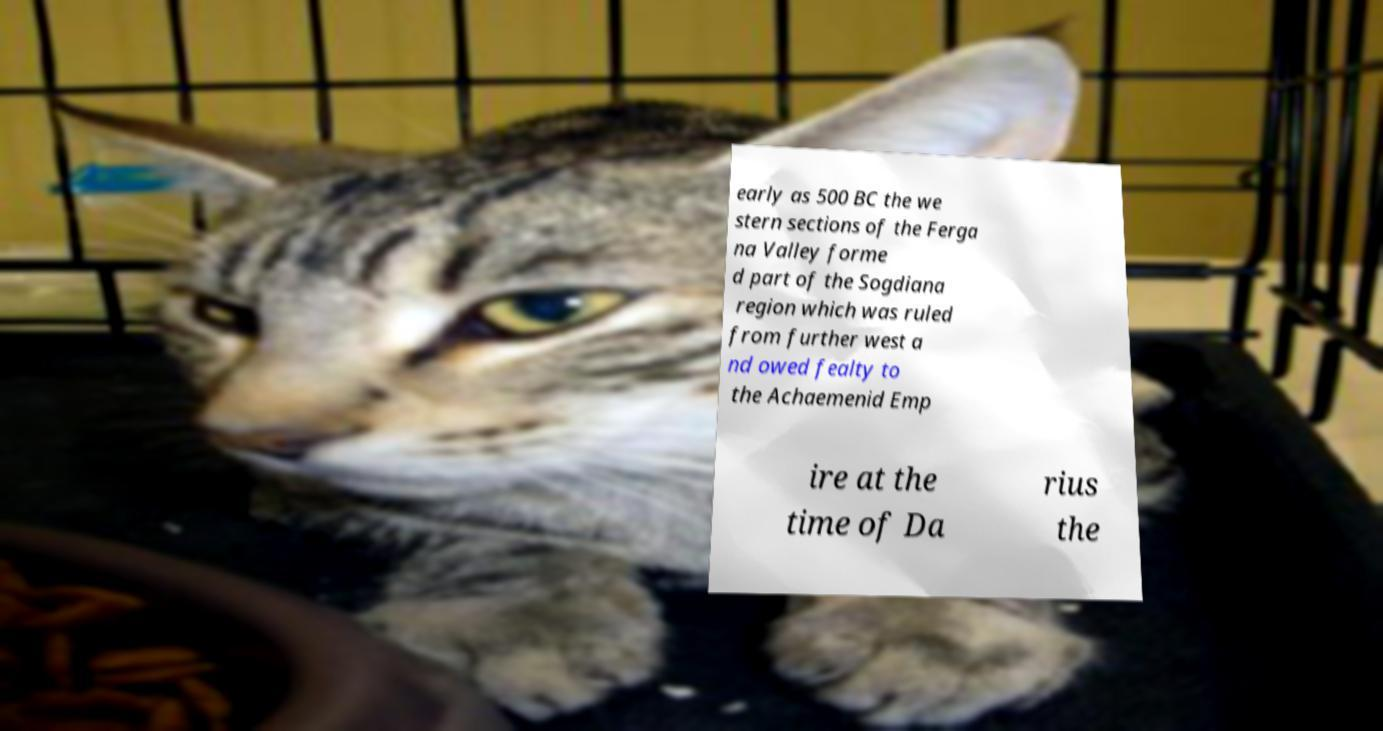What messages or text are displayed in this image? I need them in a readable, typed format. early as 500 BC the we stern sections of the Ferga na Valley forme d part of the Sogdiana region which was ruled from further west a nd owed fealty to the Achaemenid Emp ire at the time of Da rius the 